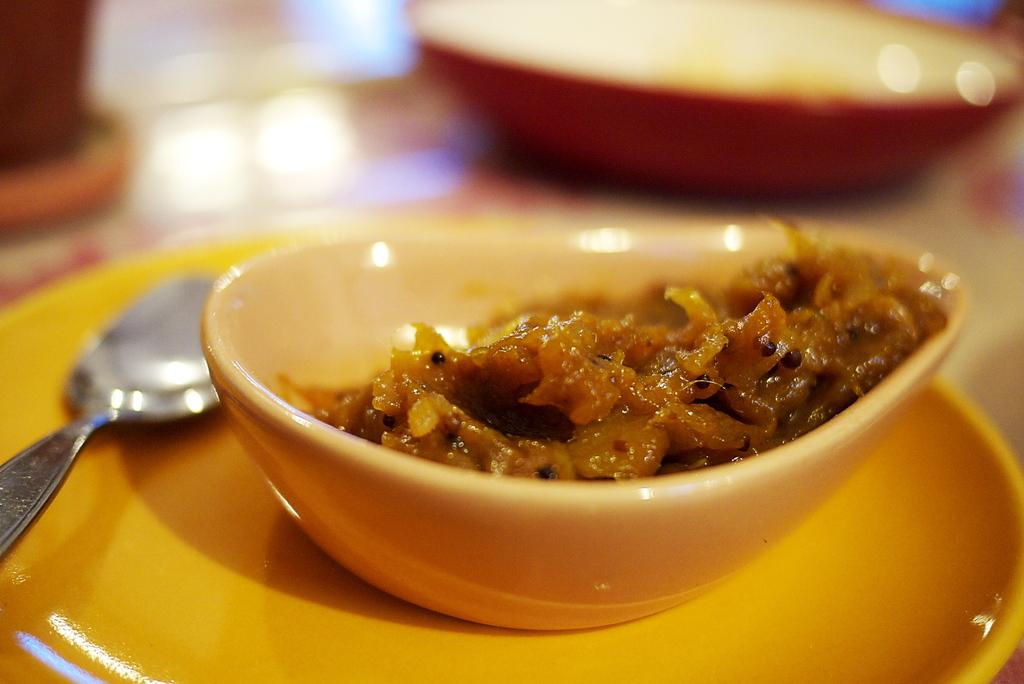What is present on the plate in the image? There is a spoon on the plate in the image. What is in the bowl that is visible in the image? There is food in a bowl in the image. Can you describe the other bowl that is visible in the image? There appears to be another bowl in the background of the image. How many grandfathers are present in the image? There is no mention of a grandfather in the image, so it cannot be determined if any are present. What type of feast is being prepared in the image? There is no indication of a feast or any food preparation in the image. 